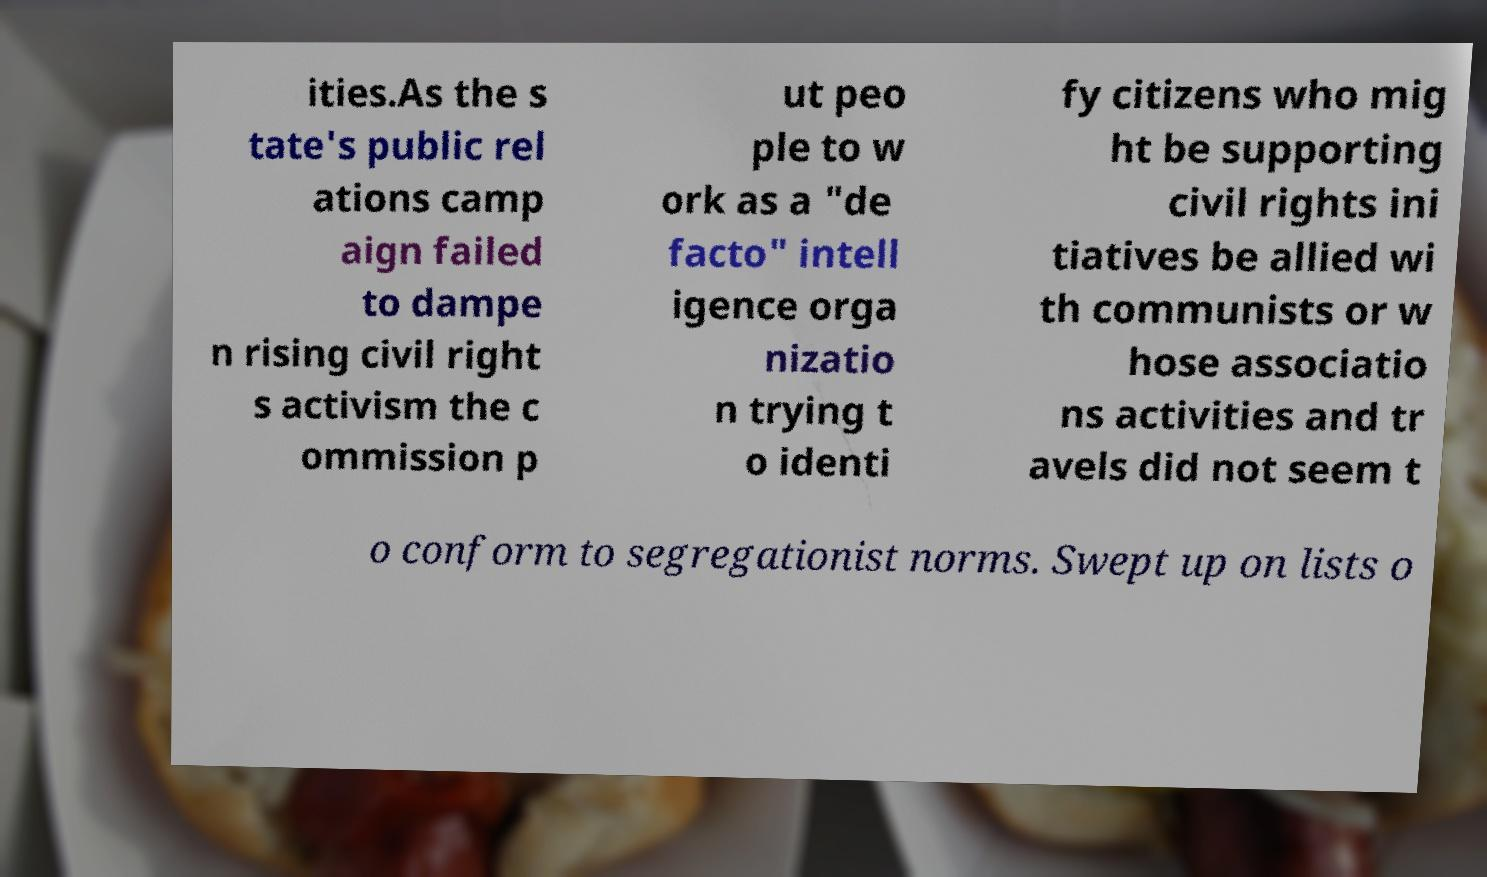Could you extract and type out the text from this image? ities.As the s tate's public rel ations camp aign failed to dampe n rising civil right s activism the c ommission p ut peo ple to w ork as a "de facto" intell igence orga nizatio n trying t o identi fy citizens who mig ht be supporting civil rights ini tiatives be allied wi th communists or w hose associatio ns activities and tr avels did not seem t o conform to segregationist norms. Swept up on lists o 